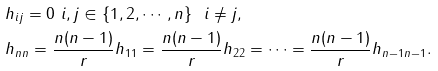Convert formula to latex. <formula><loc_0><loc_0><loc_500><loc_500>& h _ { i j } = 0 \ i , j \in \{ 1 , 2 , \cdots , n \} \ \ i \neq j , \\ & h _ { n n } = \frac { n ( n - 1 ) } { r } h _ { 1 1 } = \frac { n ( n - 1 ) } { r } h _ { 2 2 } = \cdots = \frac { n ( n - 1 ) } { r } h _ { n - 1 n - 1 } .</formula> 